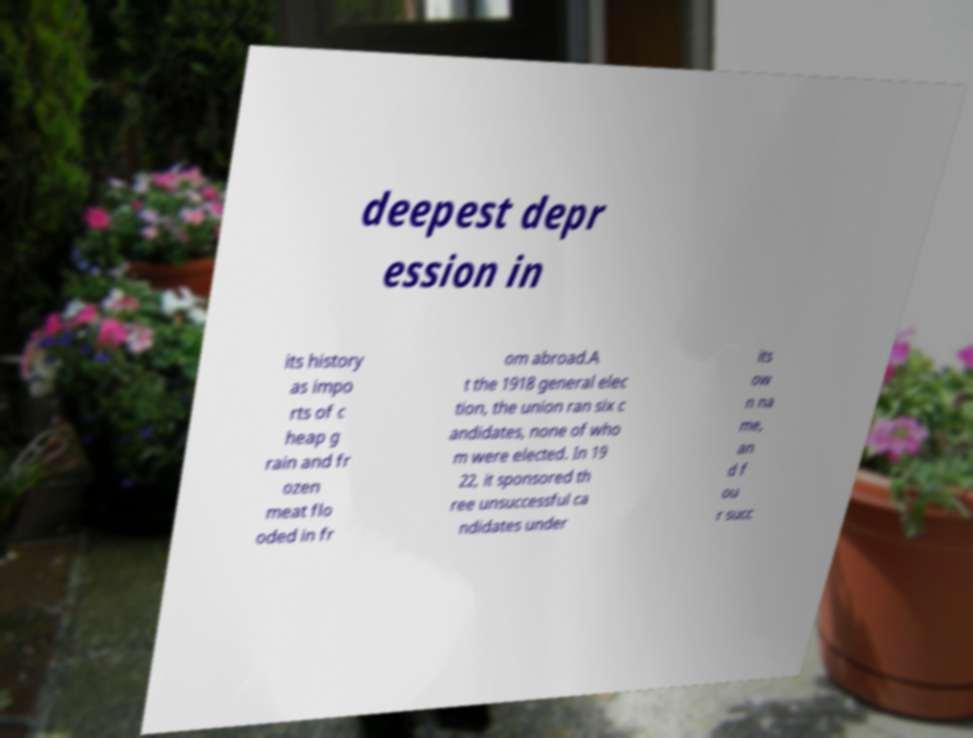Could you assist in decoding the text presented in this image and type it out clearly? deepest depr ession in its history as impo rts of c heap g rain and fr ozen meat flo oded in fr om abroad.A t the 1918 general elec tion, the union ran six c andidates, none of who m were elected. In 19 22, it sponsored th ree unsuccessful ca ndidates under its ow n na me, an d f ou r succ 